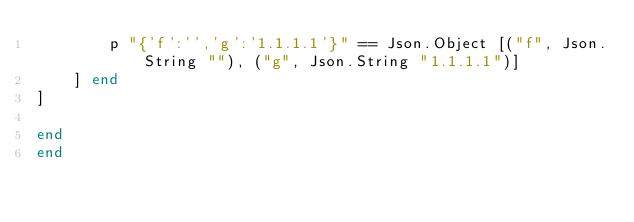<code> <loc_0><loc_0><loc_500><loc_500><_SML_>        p "{'f':'','g':'1.1.1.1'}" == Json.Object [("f", Json.String ""), ("g", Json.String "1.1.1.1")]
    ] end
]

end
end
</code> 